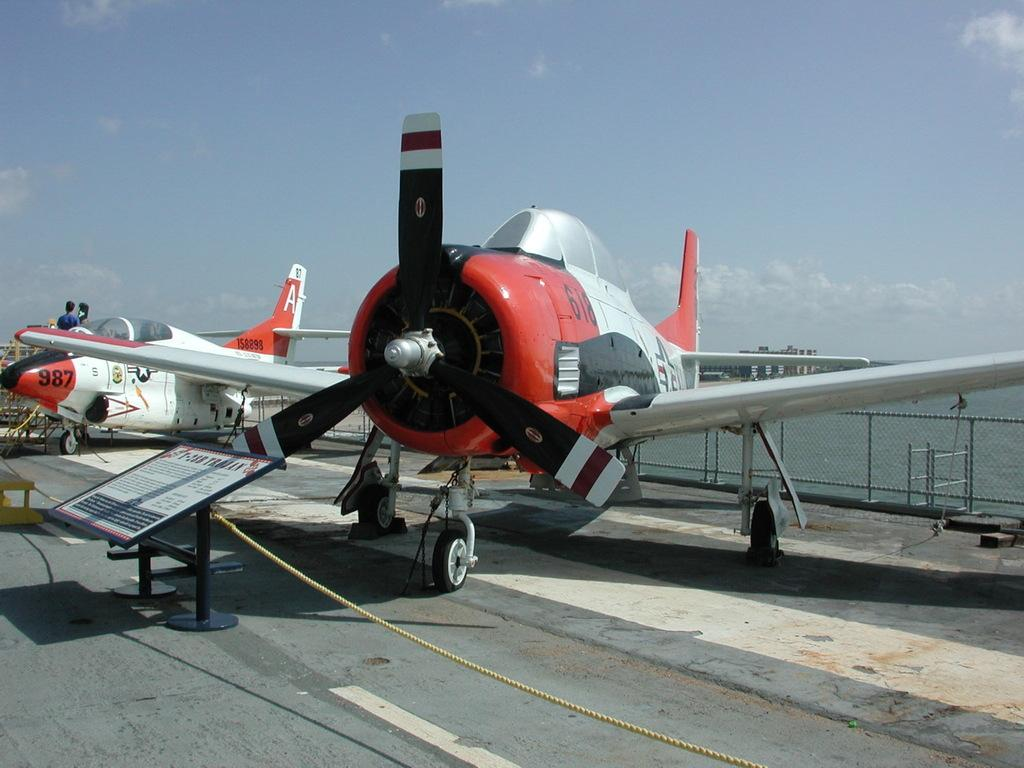Provide a one-sentence caption for the provided image. The plane in the background is a newer model with the number 987 on the nose. 